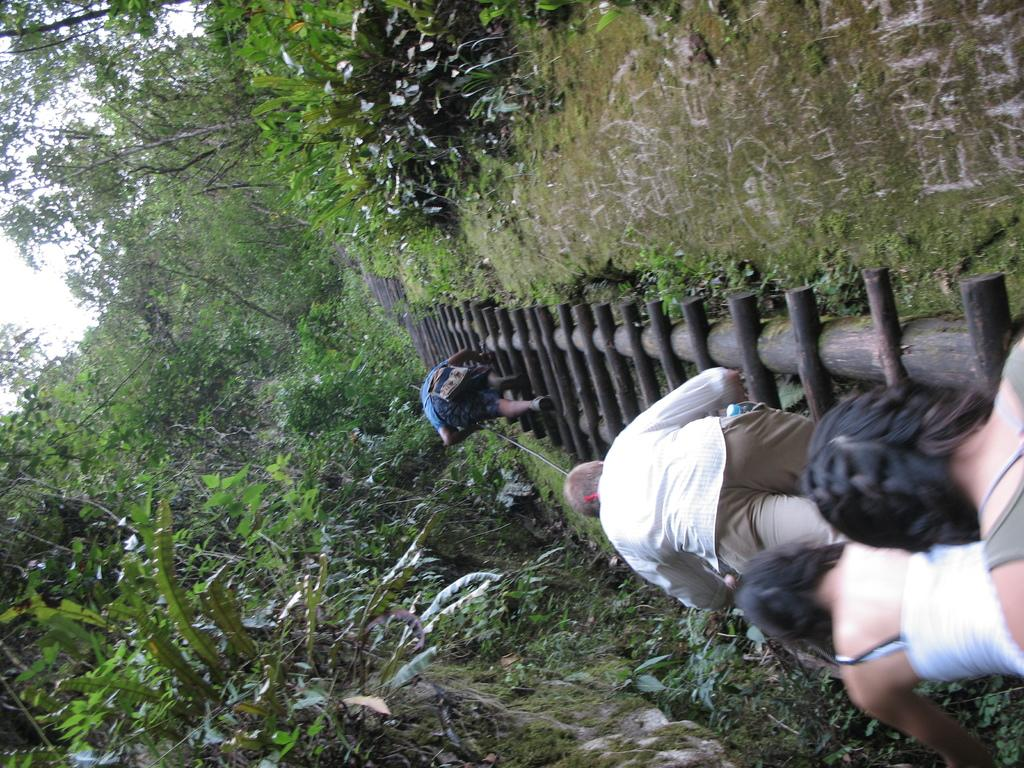How many people are present in the image? There are four people in the image. What object can be seen in the image that is used for climbing or reaching higher places? There is a ladder in the image. What type of natural vegetation is visible in the image? There are trees in the image. What else can be seen in the image besides the people and the ladder? There are some objects in the image. What is visible in the background of the image? The sky is visible in the background of the image. What invention is being demonstrated by the people in the image? There is no invention being demonstrated by the people in the image. Can you see any mountains in the background of the image? No, there are no mountains visible in the image; only trees and the sky are present in the background. 